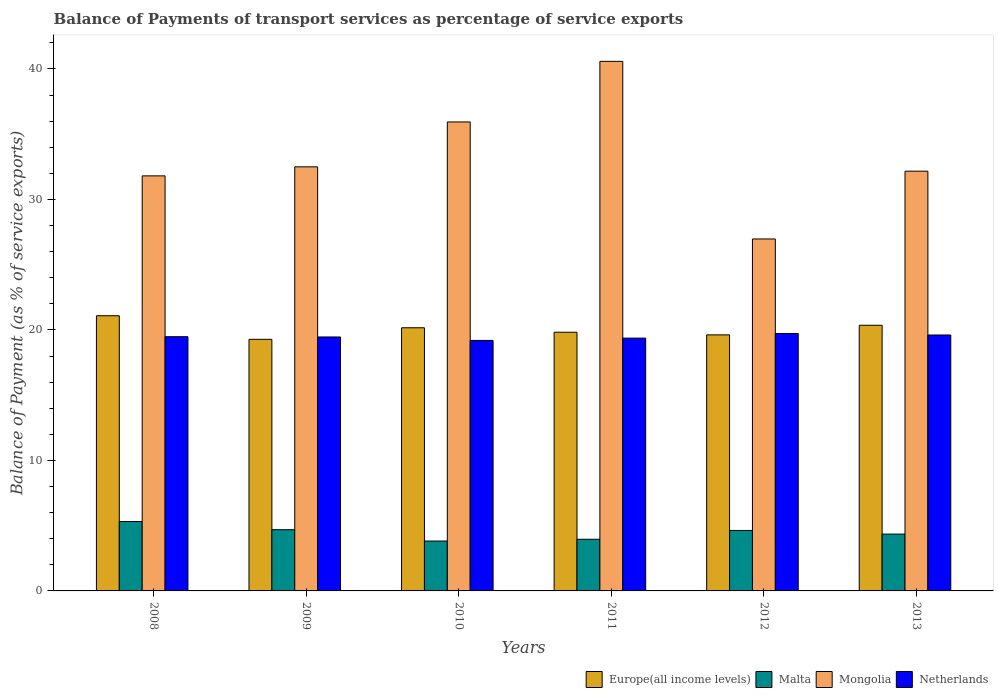Are the number of bars per tick equal to the number of legend labels?
Your response must be concise. Yes. How many bars are there on the 4th tick from the left?
Make the answer very short. 4. In how many cases, is the number of bars for a given year not equal to the number of legend labels?
Make the answer very short. 0. What is the balance of payments of transport services in Malta in 2008?
Keep it short and to the point. 5.32. Across all years, what is the maximum balance of payments of transport services in Europe(all income levels)?
Your answer should be compact. 21.09. Across all years, what is the minimum balance of payments of transport services in Europe(all income levels)?
Make the answer very short. 19.28. What is the total balance of payments of transport services in Malta in the graph?
Offer a terse response. 26.79. What is the difference between the balance of payments of transport services in Netherlands in 2009 and that in 2013?
Offer a terse response. -0.15. What is the difference between the balance of payments of transport services in Malta in 2008 and the balance of payments of transport services in Mongolia in 2009?
Your answer should be very brief. -27.18. What is the average balance of payments of transport services in Mongolia per year?
Your answer should be compact. 33.33. In the year 2013, what is the difference between the balance of payments of transport services in Netherlands and balance of payments of transport services in Malta?
Your answer should be compact. 15.26. In how many years, is the balance of payments of transport services in Netherlands greater than 28 %?
Your response must be concise. 0. What is the ratio of the balance of payments of transport services in Europe(all income levels) in 2009 to that in 2012?
Give a very brief answer. 0.98. Is the difference between the balance of payments of transport services in Netherlands in 2009 and 2010 greater than the difference between the balance of payments of transport services in Malta in 2009 and 2010?
Offer a terse response. No. What is the difference between the highest and the second highest balance of payments of transport services in Netherlands?
Offer a terse response. 0.12. What is the difference between the highest and the lowest balance of payments of transport services in Netherlands?
Make the answer very short. 0.53. Is the sum of the balance of payments of transport services in Europe(all income levels) in 2009 and 2013 greater than the maximum balance of payments of transport services in Malta across all years?
Your answer should be compact. Yes. What does the 3rd bar from the left in 2012 represents?
Give a very brief answer. Mongolia. What does the 1st bar from the right in 2013 represents?
Offer a very short reply. Netherlands. Is it the case that in every year, the sum of the balance of payments of transport services in Europe(all income levels) and balance of payments of transport services in Malta is greater than the balance of payments of transport services in Mongolia?
Your answer should be compact. No. How many years are there in the graph?
Offer a very short reply. 6. What is the difference between two consecutive major ticks on the Y-axis?
Your answer should be very brief. 10. Does the graph contain any zero values?
Keep it short and to the point. No. What is the title of the graph?
Keep it short and to the point. Balance of Payments of transport services as percentage of service exports. What is the label or title of the X-axis?
Your answer should be very brief. Years. What is the label or title of the Y-axis?
Your answer should be compact. Balance of Payment (as % of service exports). What is the Balance of Payment (as % of service exports) in Europe(all income levels) in 2008?
Offer a very short reply. 21.09. What is the Balance of Payment (as % of service exports) of Malta in 2008?
Your answer should be compact. 5.32. What is the Balance of Payment (as % of service exports) in Mongolia in 2008?
Keep it short and to the point. 31.81. What is the Balance of Payment (as % of service exports) in Netherlands in 2008?
Your answer should be very brief. 19.48. What is the Balance of Payment (as % of service exports) in Europe(all income levels) in 2009?
Keep it short and to the point. 19.28. What is the Balance of Payment (as % of service exports) of Malta in 2009?
Provide a short and direct response. 4.69. What is the Balance of Payment (as % of service exports) in Mongolia in 2009?
Make the answer very short. 32.5. What is the Balance of Payment (as % of service exports) in Netherlands in 2009?
Your response must be concise. 19.46. What is the Balance of Payment (as % of service exports) in Europe(all income levels) in 2010?
Your response must be concise. 20.17. What is the Balance of Payment (as % of service exports) in Malta in 2010?
Offer a very short reply. 3.82. What is the Balance of Payment (as % of service exports) of Mongolia in 2010?
Offer a terse response. 35.94. What is the Balance of Payment (as % of service exports) in Netherlands in 2010?
Your response must be concise. 19.2. What is the Balance of Payment (as % of service exports) in Europe(all income levels) in 2011?
Make the answer very short. 19.83. What is the Balance of Payment (as % of service exports) of Malta in 2011?
Make the answer very short. 3.96. What is the Balance of Payment (as % of service exports) in Mongolia in 2011?
Ensure brevity in your answer.  40.59. What is the Balance of Payment (as % of service exports) in Netherlands in 2011?
Give a very brief answer. 19.37. What is the Balance of Payment (as % of service exports) in Europe(all income levels) in 2012?
Your answer should be compact. 19.62. What is the Balance of Payment (as % of service exports) of Malta in 2012?
Your answer should be compact. 4.64. What is the Balance of Payment (as % of service exports) in Mongolia in 2012?
Give a very brief answer. 26.97. What is the Balance of Payment (as % of service exports) in Netherlands in 2012?
Ensure brevity in your answer.  19.73. What is the Balance of Payment (as % of service exports) of Europe(all income levels) in 2013?
Offer a very short reply. 20.36. What is the Balance of Payment (as % of service exports) in Malta in 2013?
Your answer should be very brief. 4.36. What is the Balance of Payment (as % of service exports) of Mongolia in 2013?
Your answer should be compact. 32.17. What is the Balance of Payment (as % of service exports) of Netherlands in 2013?
Provide a succinct answer. 19.61. Across all years, what is the maximum Balance of Payment (as % of service exports) of Europe(all income levels)?
Your answer should be very brief. 21.09. Across all years, what is the maximum Balance of Payment (as % of service exports) in Malta?
Provide a succinct answer. 5.32. Across all years, what is the maximum Balance of Payment (as % of service exports) in Mongolia?
Offer a terse response. 40.59. Across all years, what is the maximum Balance of Payment (as % of service exports) in Netherlands?
Ensure brevity in your answer.  19.73. Across all years, what is the minimum Balance of Payment (as % of service exports) of Europe(all income levels)?
Offer a terse response. 19.28. Across all years, what is the minimum Balance of Payment (as % of service exports) of Malta?
Your answer should be compact. 3.82. Across all years, what is the minimum Balance of Payment (as % of service exports) in Mongolia?
Your answer should be very brief. 26.97. Across all years, what is the minimum Balance of Payment (as % of service exports) of Netherlands?
Ensure brevity in your answer.  19.2. What is the total Balance of Payment (as % of service exports) in Europe(all income levels) in the graph?
Your answer should be very brief. 120.35. What is the total Balance of Payment (as % of service exports) in Malta in the graph?
Provide a short and direct response. 26.79. What is the total Balance of Payment (as % of service exports) of Mongolia in the graph?
Provide a succinct answer. 199.98. What is the total Balance of Payment (as % of service exports) in Netherlands in the graph?
Your response must be concise. 116.86. What is the difference between the Balance of Payment (as % of service exports) in Europe(all income levels) in 2008 and that in 2009?
Ensure brevity in your answer.  1.81. What is the difference between the Balance of Payment (as % of service exports) of Malta in 2008 and that in 2009?
Your response must be concise. 0.63. What is the difference between the Balance of Payment (as % of service exports) in Mongolia in 2008 and that in 2009?
Keep it short and to the point. -0.69. What is the difference between the Balance of Payment (as % of service exports) in Netherlands in 2008 and that in 2009?
Give a very brief answer. 0.02. What is the difference between the Balance of Payment (as % of service exports) in Malta in 2008 and that in 2010?
Provide a short and direct response. 1.5. What is the difference between the Balance of Payment (as % of service exports) of Mongolia in 2008 and that in 2010?
Provide a short and direct response. -4.13. What is the difference between the Balance of Payment (as % of service exports) in Netherlands in 2008 and that in 2010?
Your answer should be very brief. 0.29. What is the difference between the Balance of Payment (as % of service exports) of Europe(all income levels) in 2008 and that in 2011?
Your answer should be very brief. 1.26. What is the difference between the Balance of Payment (as % of service exports) of Malta in 2008 and that in 2011?
Provide a short and direct response. 1.36. What is the difference between the Balance of Payment (as % of service exports) of Mongolia in 2008 and that in 2011?
Make the answer very short. -8.78. What is the difference between the Balance of Payment (as % of service exports) in Netherlands in 2008 and that in 2011?
Ensure brevity in your answer.  0.11. What is the difference between the Balance of Payment (as % of service exports) in Europe(all income levels) in 2008 and that in 2012?
Your response must be concise. 1.47. What is the difference between the Balance of Payment (as % of service exports) of Malta in 2008 and that in 2012?
Make the answer very short. 0.68. What is the difference between the Balance of Payment (as % of service exports) in Mongolia in 2008 and that in 2012?
Ensure brevity in your answer.  4.84. What is the difference between the Balance of Payment (as % of service exports) of Netherlands in 2008 and that in 2012?
Your response must be concise. -0.25. What is the difference between the Balance of Payment (as % of service exports) in Europe(all income levels) in 2008 and that in 2013?
Ensure brevity in your answer.  0.73. What is the difference between the Balance of Payment (as % of service exports) in Malta in 2008 and that in 2013?
Offer a very short reply. 0.96. What is the difference between the Balance of Payment (as % of service exports) of Mongolia in 2008 and that in 2013?
Keep it short and to the point. -0.36. What is the difference between the Balance of Payment (as % of service exports) in Netherlands in 2008 and that in 2013?
Your response must be concise. -0.13. What is the difference between the Balance of Payment (as % of service exports) in Europe(all income levels) in 2009 and that in 2010?
Your response must be concise. -0.89. What is the difference between the Balance of Payment (as % of service exports) in Malta in 2009 and that in 2010?
Provide a short and direct response. 0.87. What is the difference between the Balance of Payment (as % of service exports) in Mongolia in 2009 and that in 2010?
Provide a succinct answer. -3.44. What is the difference between the Balance of Payment (as % of service exports) of Netherlands in 2009 and that in 2010?
Your answer should be compact. 0.27. What is the difference between the Balance of Payment (as % of service exports) in Europe(all income levels) in 2009 and that in 2011?
Provide a succinct answer. -0.55. What is the difference between the Balance of Payment (as % of service exports) of Malta in 2009 and that in 2011?
Offer a very short reply. 0.73. What is the difference between the Balance of Payment (as % of service exports) in Mongolia in 2009 and that in 2011?
Offer a terse response. -8.08. What is the difference between the Balance of Payment (as % of service exports) of Netherlands in 2009 and that in 2011?
Give a very brief answer. 0.09. What is the difference between the Balance of Payment (as % of service exports) of Europe(all income levels) in 2009 and that in 2012?
Offer a terse response. -0.34. What is the difference between the Balance of Payment (as % of service exports) of Malta in 2009 and that in 2012?
Make the answer very short. 0.06. What is the difference between the Balance of Payment (as % of service exports) of Mongolia in 2009 and that in 2012?
Offer a terse response. 5.53. What is the difference between the Balance of Payment (as % of service exports) in Netherlands in 2009 and that in 2012?
Your answer should be very brief. -0.27. What is the difference between the Balance of Payment (as % of service exports) of Europe(all income levels) in 2009 and that in 2013?
Ensure brevity in your answer.  -1.08. What is the difference between the Balance of Payment (as % of service exports) in Malta in 2009 and that in 2013?
Give a very brief answer. 0.34. What is the difference between the Balance of Payment (as % of service exports) of Mongolia in 2009 and that in 2013?
Offer a terse response. 0.33. What is the difference between the Balance of Payment (as % of service exports) of Netherlands in 2009 and that in 2013?
Your answer should be very brief. -0.15. What is the difference between the Balance of Payment (as % of service exports) in Europe(all income levels) in 2010 and that in 2011?
Your response must be concise. 0.34. What is the difference between the Balance of Payment (as % of service exports) of Malta in 2010 and that in 2011?
Offer a terse response. -0.14. What is the difference between the Balance of Payment (as % of service exports) in Mongolia in 2010 and that in 2011?
Provide a succinct answer. -4.64. What is the difference between the Balance of Payment (as % of service exports) of Netherlands in 2010 and that in 2011?
Provide a short and direct response. -0.18. What is the difference between the Balance of Payment (as % of service exports) of Europe(all income levels) in 2010 and that in 2012?
Provide a succinct answer. 0.54. What is the difference between the Balance of Payment (as % of service exports) of Malta in 2010 and that in 2012?
Provide a short and direct response. -0.81. What is the difference between the Balance of Payment (as % of service exports) of Mongolia in 2010 and that in 2012?
Keep it short and to the point. 8.97. What is the difference between the Balance of Payment (as % of service exports) of Netherlands in 2010 and that in 2012?
Provide a short and direct response. -0.53. What is the difference between the Balance of Payment (as % of service exports) of Europe(all income levels) in 2010 and that in 2013?
Keep it short and to the point. -0.19. What is the difference between the Balance of Payment (as % of service exports) of Malta in 2010 and that in 2013?
Make the answer very short. -0.53. What is the difference between the Balance of Payment (as % of service exports) in Mongolia in 2010 and that in 2013?
Your response must be concise. 3.77. What is the difference between the Balance of Payment (as % of service exports) in Netherlands in 2010 and that in 2013?
Provide a succinct answer. -0.42. What is the difference between the Balance of Payment (as % of service exports) of Europe(all income levels) in 2011 and that in 2012?
Give a very brief answer. 0.2. What is the difference between the Balance of Payment (as % of service exports) of Malta in 2011 and that in 2012?
Provide a short and direct response. -0.68. What is the difference between the Balance of Payment (as % of service exports) of Mongolia in 2011 and that in 2012?
Offer a terse response. 13.61. What is the difference between the Balance of Payment (as % of service exports) in Netherlands in 2011 and that in 2012?
Your response must be concise. -0.36. What is the difference between the Balance of Payment (as % of service exports) of Europe(all income levels) in 2011 and that in 2013?
Give a very brief answer. -0.53. What is the difference between the Balance of Payment (as % of service exports) of Malta in 2011 and that in 2013?
Make the answer very short. -0.4. What is the difference between the Balance of Payment (as % of service exports) in Mongolia in 2011 and that in 2013?
Keep it short and to the point. 8.42. What is the difference between the Balance of Payment (as % of service exports) of Netherlands in 2011 and that in 2013?
Your answer should be very brief. -0.24. What is the difference between the Balance of Payment (as % of service exports) in Europe(all income levels) in 2012 and that in 2013?
Provide a short and direct response. -0.73. What is the difference between the Balance of Payment (as % of service exports) in Malta in 2012 and that in 2013?
Ensure brevity in your answer.  0.28. What is the difference between the Balance of Payment (as % of service exports) of Mongolia in 2012 and that in 2013?
Keep it short and to the point. -5.19. What is the difference between the Balance of Payment (as % of service exports) of Netherlands in 2012 and that in 2013?
Your answer should be compact. 0.12. What is the difference between the Balance of Payment (as % of service exports) in Europe(all income levels) in 2008 and the Balance of Payment (as % of service exports) in Malta in 2009?
Provide a succinct answer. 16.4. What is the difference between the Balance of Payment (as % of service exports) in Europe(all income levels) in 2008 and the Balance of Payment (as % of service exports) in Mongolia in 2009?
Provide a succinct answer. -11.41. What is the difference between the Balance of Payment (as % of service exports) in Europe(all income levels) in 2008 and the Balance of Payment (as % of service exports) in Netherlands in 2009?
Ensure brevity in your answer.  1.63. What is the difference between the Balance of Payment (as % of service exports) in Malta in 2008 and the Balance of Payment (as % of service exports) in Mongolia in 2009?
Provide a short and direct response. -27.18. What is the difference between the Balance of Payment (as % of service exports) of Malta in 2008 and the Balance of Payment (as % of service exports) of Netherlands in 2009?
Give a very brief answer. -14.14. What is the difference between the Balance of Payment (as % of service exports) in Mongolia in 2008 and the Balance of Payment (as % of service exports) in Netherlands in 2009?
Make the answer very short. 12.35. What is the difference between the Balance of Payment (as % of service exports) of Europe(all income levels) in 2008 and the Balance of Payment (as % of service exports) of Malta in 2010?
Your answer should be very brief. 17.27. What is the difference between the Balance of Payment (as % of service exports) in Europe(all income levels) in 2008 and the Balance of Payment (as % of service exports) in Mongolia in 2010?
Your response must be concise. -14.85. What is the difference between the Balance of Payment (as % of service exports) in Europe(all income levels) in 2008 and the Balance of Payment (as % of service exports) in Netherlands in 2010?
Offer a very short reply. 1.89. What is the difference between the Balance of Payment (as % of service exports) of Malta in 2008 and the Balance of Payment (as % of service exports) of Mongolia in 2010?
Give a very brief answer. -30.62. What is the difference between the Balance of Payment (as % of service exports) in Malta in 2008 and the Balance of Payment (as % of service exports) in Netherlands in 2010?
Ensure brevity in your answer.  -13.88. What is the difference between the Balance of Payment (as % of service exports) of Mongolia in 2008 and the Balance of Payment (as % of service exports) of Netherlands in 2010?
Offer a very short reply. 12.61. What is the difference between the Balance of Payment (as % of service exports) of Europe(all income levels) in 2008 and the Balance of Payment (as % of service exports) of Malta in 2011?
Keep it short and to the point. 17.13. What is the difference between the Balance of Payment (as % of service exports) of Europe(all income levels) in 2008 and the Balance of Payment (as % of service exports) of Mongolia in 2011?
Keep it short and to the point. -19.49. What is the difference between the Balance of Payment (as % of service exports) of Europe(all income levels) in 2008 and the Balance of Payment (as % of service exports) of Netherlands in 2011?
Provide a short and direct response. 1.72. What is the difference between the Balance of Payment (as % of service exports) in Malta in 2008 and the Balance of Payment (as % of service exports) in Mongolia in 2011?
Your response must be concise. -35.27. What is the difference between the Balance of Payment (as % of service exports) of Malta in 2008 and the Balance of Payment (as % of service exports) of Netherlands in 2011?
Offer a terse response. -14.05. What is the difference between the Balance of Payment (as % of service exports) in Mongolia in 2008 and the Balance of Payment (as % of service exports) in Netherlands in 2011?
Make the answer very short. 12.43. What is the difference between the Balance of Payment (as % of service exports) in Europe(all income levels) in 2008 and the Balance of Payment (as % of service exports) in Malta in 2012?
Your answer should be compact. 16.46. What is the difference between the Balance of Payment (as % of service exports) in Europe(all income levels) in 2008 and the Balance of Payment (as % of service exports) in Mongolia in 2012?
Your response must be concise. -5.88. What is the difference between the Balance of Payment (as % of service exports) in Europe(all income levels) in 2008 and the Balance of Payment (as % of service exports) in Netherlands in 2012?
Your answer should be very brief. 1.36. What is the difference between the Balance of Payment (as % of service exports) of Malta in 2008 and the Balance of Payment (as % of service exports) of Mongolia in 2012?
Your answer should be compact. -21.65. What is the difference between the Balance of Payment (as % of service exports) of Malta in 2008 and the Balance of Payment (as % of service exports) of Netherlands in 2012?
Ensure brevity in your answer.  -14.41. What is the difference between the Balance of Payment (as % of service exports) of Mongolia in 2008 and the Balance of Payment (as % of service exports) of Netherlands in 2012?
Offer a very short reply. 12.08. What is the difference between the Balance of Payment (as % of service exports) of Europe(all income levels) in 2008 and the Balance of Payment (as % of service exports) of Malta in 2013?
Make the answer very short. 16.73. What is the difference between the Balance of Payment (as % of service exports) of Europe(all income levels) in 2008 and the Balance of Payment (as % of service exports) of Mongolia in 2013?
Keep it short and to the point. -11.08. What is the difference between the Balance of Payment (as % of service exports) of Europe(all income levels) in 2008 and the Balance of Payment (as % of service exports) of Netherlands in 2013?
Offer a very short reply. 1.48. What is the difference between the Balance of Payment (as % of service exports) of Malta in 2008 and the Balance of Payment (as % of service exports) of Mongolia in 2013?
Ensure brevity in your answer.  -26.85. What is the difference between the Balance of Payment (as % of service exports) of Malta in 2008 and the Balance of Payment (as % of service exports) of Netherlands in 2013?
Your answer should be compact. -14.29. What is the difference between the Balance of Payment (as % of service exports) in Mongolia in 2008 and the Balance of Payment (as % of service exports) in Netherlands in 2013?
Offer a terse response. 12.19. What is the difference between the Balance of Payment (as % of service exports) of Europe(all income levels) in 2009 and the Balance of Payment (as % of service exports) of Malta in 2010?
Keep it short and to the point. 15.46. What is the difference between the Balance of Payment (as % of service exports) in Europe(all income levels) in 2009 and the Balance of Payment (as % of service exports) in Mongolia in 2010?
Ensure brevity in your answer.  -16.66. What is the difference between the Balance of Payment (as % of service exports) of Europe(all income levels) in 2009 and the Balance of Payment (as % of service exports) of Netherlands in 2010?
Keep it short and to the point. 0.08. What is the difference between the Balance of Payment (as % of service exports) in Malta in 2009 and the Balance of Payment (as % of service exports) in Mongolia in 2010?
Ensure brevity in your answer.  -31.25. What is the difference between the Balance of Payment (as % of service exports) in Malta in 2009 and the Balance of Payment (as % of service exports) in Netherlands in 2010?
Your answer should be compact. -14.51. What is the difference between the Balance of Payment (as % of service exports) of Mongolia in 2009 and the Balance of Payment (as % of service exports) of Netherlands in 2010?
Your answer should be compact. 13.3. What is the difference between the Balance of Payment (as % of service exports) of Europe(all income levels) in 2009 and the Balance of Payment (as % of service exports) of Malta in 2011?
Your answer should be very brief. 15.32. What is the difference between the Balance of Payment (as % of service exports) in Europe(all income levels) in 2009 and the Balance of Payment (as % of service exports) in Mongolia in 2011?
Your response must be concise. -21.3. What is the difference between the Balance of Payment (as % of service exports) in Europe(all income levels) in 2009 and the Balance of Payment (as % of service exports) in Netherlands in 2011?
Ensure brevity in your answer.  -0.09. What is the difference between the Balance of Payment (as % of service exports) in Malta in 2009 and the Balance of Payment (as % of service exports) in Mongolia in 2011?
Your response must be concise. -35.89. What is the difference between the Balance of Payment (as % of service exports) of Malta in 2009 and the Balance of Payment (as % of service exports) of Netherlands in 2011?
Offer a terse response. -14.68. What is the difference between the Balance of Payment (as % of service exports) of Mongolia in 2009 and the Balance of Payment (as % of service exports) of Netherlands in 2011?
Keep it short and to the point. 13.13. What is the difference between the Balance of Payment (as % of service exports) in Europe(all income levels) in 2009 and the Balance of Payment (as % of service exports) in Malta in 2012?
Provide a succinct answer. 14.65. What is the difference between the Balance of Payment (as % of service exports) in Europe(all income levels) in 2009 and the Balance of Payment (as % of service exports) in Mongolia in 2012?
Offer a terse response. -7.69. What is the difference between the Balance of Payment (as % of service exports) in Europe(all income levels) in 2009 and the Balance of Payment (as % of service exports) in Netherlands in 2012?
Provide a short and direct response. -0.45. What is the difference between the Balance of Payment (as % of service exports) of Malta in 2009 and the Balance of Payment (as % of service exports) of Mongolia in 2012?
Keep it short and to the point. -22.28. What is the difference between the Balance of Payment (as % of service exports) of Malta in 2009 and the Balance of Payment (as % of service exports) of Netherlands in 2012?
Your response must be concise. -15.04. What is the difference between the Balance of Payment (as % of service exports) of Mongolia in 2009 and the Balance of Payment (as % of service exports) of Netherlands in 2012?
Make the answer very short. 12.77. What is the difference between the Balance of Payment (as % of service exports) of Europe(all income levels) in 2009 and the Balance of Payment (as % of service exports) of Malta in 2013?
Offer a very short reply. 14.92. What is the difference between the Balance of Payment (as % of service exports) in Europe(all income levels) in 2009 and the Balance of Payment (as % of service exports) in Mongolia in 2013?
Give a very brief answer. -12.89. What is the difference between the Balance of Payment (as % of service exports) in Europe(all income levels) in 2009 and the Balance of Payment (as % of service exports) in Netherlands in 2013?
Ensure brevity in your answer.  -0.33. What is the difference between the Balance of Payment (as % of service exports) in Malta in 2009 and the Balance of Payment (as % of service exports) in Mongolia in 2013?
Your answer should be compact. -27.48. What is the difference between the Balance of Payment (as % of service exports) in Malta in 2009 and the Balance of Payment (as % of service exports) in Netherlands in 2013?
Your response must be concise. -14.92. What is the difference between the Balance of Payment (as % of service exports) in Mongolia in 2009 and the Balance of Payment (as % of service exports) in Netherlands in 2013?
Offer a very short reply. 12.89. What is the difference between the Balance of Payment (as % of service exports) in Europe(all income levels) in 2010 and the Balance of Payment (as % of service exports) in Malta in 2011?
Provide a succinct answer. 16.21. What is the difference between the Balance of Payment (as % of service exports) in Europe(all income levels) in 2010 and the Balance of Payment (as % of service exports) in Mongolia in 2011?
Give a very brief answer. -20.42. What is the difference between the Balance of Payment (as % of service exports) in Europe(all income levels) in 2010 and the Balance of Payment (as % of service exports) in Netherlands in 2011?
Ensure brevity in your answer.  0.79. What is the difference between the Balance of Payment (as % of service exports) in Malta in 2010 and the Balance of Payment (as % of service exports) in Mongolia in 2011?
Your answer should be compact. -36.76. What is the difference between the Balance of Payment (as % of service exports) of Malta in 2010 and the Balance of Payment (as % of service exports) of Netherlands in 2011?
Your answer should be very brief. -15.55. What is the difference between the Balance of Payment (as % of service exports) in Mongolia in 2010 and the Balance of Payment (as % of service exports) in Netherlands in 2011?
Your answer should be very brief. 16.57. What is the difference between the Balance of Payment (as % of service exports) in Europe(all income levels) in 2010 and the Balance of Payment (as % of service exports) in Malta in 2012?
Your response must be concise. 15.53. What is the difference between the Balance of Payment (as % of service exports) of Europe(all income levels) in 2010 and the Balance of Payment (as % of service exports) of Mongolia in 2012?
Your response must be concise. -6.81. What is the difference between the Balance of Payment (as % of service exports) of Europe(all income levels) in 2010 and the Balance of Payment (as % of service exports) of Netherlands in 2012?
Your response must be concise. 0.44. What is the difference between the Balance of Payment (as % of service exports) in Malta in 2010 and the Balance of Payment (as % of service exports) in Mongolia in 2012?
Provide a succinct answer. -23.15. What is the difference between the Balance of Payment (as % of service exports) of Malta in 2010 and the Balance of Payment (as % of service exports) of Netherlands in 2012?
Provide a short and direct response. -15.91. What is the difference between the Balance of Payment (as % of service exports) of Mongolia in 2010 and the Balance of Payment (as % of service exports) of Netherlands in 2012?
Ensure brevity in your answer.  16.21. What is the difference between the Balance of Payment (as % of service exports) of Europe(all income levels) in 2010 and the Balance of Payment (as % of service exports) of Malta in 2013?
Keep it short and to the point. 15.81. What is the difference between the Balance of Payment (as % of service exports) of Europe(all income levels) in 2010 and the Balance of Payment (as % of service exports) of Mongolia in 2013?
Your response must be concise. -12. What is the difference between the Balance of Payment (as % of service exports) of Europe(all income levels) in 2010 and the Balance of Payment (as % of service exports) of Netherlands in 2013?
Offer a very short reply. 0.55. What is the difference between the Balance of Payment (as % of service exports) in Malta in 2010 and the Balance of Payment (as % of service exports) in Mongolia in 2013?
Provide a succinct answer. -28.35. What is the difference between the Balance of Payment (as % of service exports) in Malta in 2010 and the Balance of Payment (as % of service exports) in Netherlands in 2013?
Make the answer very short. -15.79. What is the difference between the Balance of Payment (as % of service exports) in Mongolia in 2010 and the Balance of Payment (as % of service exports) in Netherlands in 2013?
Provide a succinct answer. 16.33. What is the difference between the Balance of Payment (as % of service exports) in Europe(all income levels) in 2011 and the Balance of Payment (as % of service exports) in Malta in 2012?
Keep it short and to the point. 15.19. What is the difference between the Balance of Payment (as % of service exports) of Europe(all income levels) in 2011 and the Balance of Payment (as % of service exports) of Mongolia in 2012?
Ensure brevity in your answer.  -7.15. What is the difference between the Balance of Payment (as % of service exports) of Europe(all income levels) in 2011 and the Balance of Payment (as % of service exports) of Netherlands in 2012?
Ensure brevity in your answer.  0.1. What is the difference between the Balance of Payment (as % of service exports) in Malta in 2011 and the Balance of Payment (as % of service exports) in Mongolia in 2012?
Offer a terse response. -23.01. What is the difference between the Balance of Payment (as % of service exports) in Malta in 2011 and the Balance of Payment (as % of service exports) in Netherlands in 2012?
Ensure brevity in your answer.  -15.77. What is the difference between the Balance of Payment (as % of service exports) in Mongolia in 2011 and the Balance of Payment (as % of service exports) in Netherlands in 2012?
Keep it short and to the point. 20.86. What is the difference between the Balance of Payment (as % of service exports) in Europe(all income levels) in 2011 and the Balance of Payment (as % of service exports) in Malta in 2013?
Your answer should be compact. 15.47. What is the difference between the Balance of Payment (as % of service exports) of Europe(all income levels) in 2011 and the Balance of Payment (as % of service exports) of Mongolia in 2013?
Keep it short and to the point. -12.34. What is the difference between the Balance of Payment (as % of service exports) in Europe(all income levels) in 2011 and the Balance of Payment (as % of service exports) in Netherlands in 2013?
Offer a very short reply. 0.21. What is the difference between the Balance of Payment (as % of service exports) in Malta in 2011 and the Balance of Payment (as % of service exports) in Mongolia in 2013?
Your response must be concise. -28.21. What is the difference between the Balance of Payment (as % of service exports) in Malta in 2011 and the Balance of Payment (as % of service exports) in Netherlands in 2013?
Offer a terse response. -15.65. What is the difference between the Balance of Payment (as % of service exports) in Mongolia in 2011 and the Balance of Payment (as % of service exports) in Netherlands in 2013?
Your answer should be compact. 20.97. What is the difference between the Balance of Payment (as % of service exports) in Europe(all income levels) in 2012 and the Balance of Payment (as % of service exports) in Malta in 2013?
Your response must be concise. 15.27. What is the difference between the Balance of Payment (as % of service exports) in Europe(all income levels) in 2012 and the Balance of Payment (as % of service exports) in Mongolia in 2013?
Provide a short and direct response. -12.54. What is the difference between the Balance of Payment (as % of service exports) of Europe(all income levels) in 2012 and the Balance of Payment (as % of service exports) of Netherlands in 2013?
Give a very brief answer. 0.01. What is the difference between the Balance of Payment (as % of service exports) of Malta in 2012 and the Balance of Payment (as % of service exports) of Mongolia in 2013?
Give a very brief answer. -27.53. What is the difference between the Balance of Payment (as % of service exports) in Malta in 2012 and the Balance of Payment (as % of service exports) in Netherlands in 2013?
Your response must be concise. -14.98. What is the difference between the Balance of Payment (as % of service exports) in Mongolia in 2012 and the Balance of Payment (as % of service exports) in Netherlands in 2013?
Make the answer very short. 7.36. What is the average Balance of Payment (as % of service exports) of Europe(all income levels) per year?
Your response must be concise. 20.06. What is the average Balance of Payment (as % of service exports) in Malta per year?
Ensure brevity in your answer.  4.46. What is the average Balance of Payment (as % of service exports) of Mongolia per year?
Make the answer very short. 33.33. What is the average Balance of Payment (as % of service exports) of Netherlands per year?
Your answer should be compact. 19.48. In the year 2008, what is the difference between the Balance of Payment (as % of service exports) in Europe(all income levels) and Balance of Payment (as % of service exports) in Malta?
Offer a very short reply. 15.77. In the year 2008, what is the difference between the Balance of Payment (as % of service exports) in Europe(all income levels) and Balance of Payment (as % of service exports) in Mongolia?
Ensure brevity in your answer.  -10.72. In the year 2008, what is the difference between the Balance of Payment (as % of service exports) in Europe(all income levels) and Balance of Payment (as % of service exports) in Netherlands?
Give a very brief answer. 1.61. In the year 2008, what is the difference between the Balance of Payment (as % of service exports) of Malta and Balance of Payment (as % of service exports) of Mongolia?
Your answer should be compact. -26.49. In the year 2008, what is the difference between the Balance of Payment (as % of service exports) of Malta and Balance of Payment (as % of service exports) of Netherlands?
Ensure brevity in your answer.  -14.16. In the year 2008, what is the difference between the Balance of Payment (as % of service exports) of Mongolia and Balance of Payment (as % of service exports) of Netherlands?
Your answer should be very brief. 12.33. In the year 2009, what is the difference between the Balance of Payment (as % of service exports) of Europe(all income levels) and Balance of Payment (as % of service exports) of Malta?
Make the answer very short. 14.59. In the year 2009, what is the difference between the Balance of Payment (as % of service exports) of Europe(all income levels) and Balance of Payment (as % of service exports) of Mongolia?
Keep it short and to the point. -13.22. In the year 2009, what is the difference between the Balance of Payment (as % of service exports) in Europe(all income levels) and Balance of Payment (as % of service exports) in Netherlands?
Your response must be concise. -0.18. In the year 2009, what is the difference between the Balance of Payment (as % of service exports) of Malta and Balance of Payment (as % of service exports) of Mongolia?
Make the answer very short. -27.81. In the year 2009, what is the difference between the Balance of Payment (as % of service exports) in Malta and Balance of Payment (as % of service exports) in Netherlands?
Keep it short and to the point. -14.77. In the year 2009, what is the difference between the Balance of Payment (as % of service exports) in Mongolia and Balance of Payment (as % of service exports) in Netherlands?
Give a very brief answer. 13.04. In the year 2010, what is the difference between the Balance of Payment (as % of service exports) of Europe(all income levels) and Balance of Payment (as % of service exports) of Malta?
Give a very brief answer. 16.34. In the year 2010, what is the difference between the Balance of Payment (as % of service exports) of Europe(all income levels) and Balance of Payment (as % of service exports) of Mongolia?
Keep it short and to the point. -15.77. In the year 2010, what is the difference between the Balance of Payment (as % of service exports) of Europe(all income levels) and Balance of Payment (as % of service exports) of Netherlands?
Your response must be concise. 0.97. In the year 2010, what is the difference between the Balance of Payment (as % of service exports) in Malta and Balance of Payment (as % of service exports) in Mongolia?
Ensure brevity in your answer.  -32.12. In the year 2010, what is the difference between the Balance of Payment (as % of service exports) in Malta and Balance of Payment (as % of service exports) in Netherlands?
Make the answer very short. -15.37. In the year 2010, what is the difference between the Balance of Payment (as % of service exports) in Mongolia and Balance of Payment (as % of service exports) in Netherlands?
Give a very brief answer. 16.74. In the year 2011, what is the difference between the Balance of Payment (as % of service exports) in Europe(all income levels) and Balance of Payment (as % of service exports) in Malta?
Your response must be concise. 15.87. In the year 2011, what is the difference between the Balance of Payment (as % of service exports) in Europe(all income levels) and Balance of Payment (as % of service exports) in Mongolia?
Give a very brief answer. -20.76. In the year 2011, what is the difference between the Balance of Payment (as % of service exports) of Europe(all income levels) and Balance of Payment (as % of service exports) of Netherlands?
Offer a very short reply. 0.45. In the year 2011, what is the difference between the Balance of Payment (as % of service exports) of Malta and Balance of Payment (as % of service exports) of Mongolia?
Make the answer very short. -36.63. In the year 2011, what is the difference between the Balance of Payment (as % of service exports) of Malta and Balance of Payment (as % of service exports) of Netherlands?
Make the answer very short. -15.41. In the year 2011, what is the difference between the Balance of Payment (as % of service exports) of Mongolia and Balance of Payment (as % of service exports) of Netherlands?
Your response must be concise. 21.21. In the year 2012, what is the difference between the Balance of Payment (as % of service exports) in Europe(all income levels) and Balance of Payment (as % of service exports) in Malta?
Your answer should be very brief. 14.99. In the year 2012, what is the difference between the Balance of Payment (as % of service exports) of Europe(all income levels) and Balance of Payment (as % of service exports) of Mongolia?
Provide a short and direct response. -7.35. In the year 2012, what is the difference between the Balance of Payment (as % of service exports) in Europe(all income levels) and Balance of Payment (as % of service exports) in Netherlands?
Keep it short and to the point. -0.11. In the year 2012, what is the difference between the Balance of Payment (as % of service exports) of Malta and Balance of Payment (as % of service exports) of Mongolia?
Offer a terse response. -22.34. In the year 2012, what is the difference between the Balance of Payment (as % of service exports) of Malta and Balance of Payment (as % of service exports) of Netherlands?
Your answer should be very brief. -15.09. In the year 2012, what is the difference between the Balance of Payment (as % of service exports) in Mongolia and Balance of Payment (as % of service exports) in Netherlands?
Offer a terse response. 7.24. In the year 2013, what is the difference between the Balance of Payment (as % of service exports) in Europe(all income levels) and Balance of Payment (as % of service exports) in Malta?
Provide a succinct answer. 16. In the year 2013, what is the difference between the Balance of Payment (as % of service exports) in Europe(all income levels) and Balance of Payment (as % of service exports) in Mongolia?
Make the answer very short. -11.81. In the year 2013, what is the difference between the Balance of Payment (as % of service exports) in Europe(all income levels) and Balance of Payment (as % of service exports) in Netherlands?
Your answer should be very brief. 0.74. In the year 2013, what is the difference between the Balance of Payment (as % of service exports) of Malta and Balance of Payment (as % of service exports) of Mongolia?
Keep it short and to the point. -27.81. In the year 2013, what is the difference between the Balance of Payment (as % of service exports) of Malta and Balance of Payment (as % of service exports) of Netherlands?
Ensure brevity in your answer.  -15.26. In the year 2013, what is the difference between the Balance of Payment (as % of service exports) in Mongolia and Balance of Payment (as % of service exports) in Netherlands?
Offer a terse response. 12.55. What is the ratio of the Balance of Payment (as % of service exports) in Europe(all income levels) in 2008 to that in 2009?
Offer a terse response. 1.09. What is the ratio of the Balance of Payment (as % of service exports) of Malta in 2008 to that in 2009?
Provide a short and direct response. 1.13. What is the ratio of the Balance of Payment (as % of service exports) in Mongolia in 2008 to that in 2009?
Ensure brevity in your answer.  0.98. What is the ratio of the Balance of Payment (as % of service exports) of Europe(all income levels) in 2008 to that in 2010?
Give a very brief answer. 1.05. What is the ratio of the Balance of Payment (as % of service exports) of Malta in 2008 to that in 2010?
Offer a very short reply. 1.39. What is the ratio of the Balance of Payment (as % of service exports) in Mongolia in 2008 to that in 2010?
Offer a terse response. 0.89. What is the ratio of the Balance of Payment (as % of service exports) of Netherlands in 2008 to that in 2010?
Make the answer very short. 1.01. What is the ratio of the Balance of Payment (as % of service exports) in Europe(all income levels) in 2008 to that in 2011?
Offer a terse response. 1.06. What is the ratio of the Balance of Payment (as % of service exports) of Malta in 2008 to that in 2011?
Offer a terse response. 1.34. What is the ratio of the Balance of Payment (as % of service exports) of Mongolia in 2008 to that in 2011?
Ensure brevity in your answer.  0.78. What is the ratio of the Balance of Payment (as % of service exports) of Netherlands in 2008 to that in 2011?
Make the answer very short. 1.01. What is the ratio of the Balance of Payment (as % of service exports) in Europe(all income levels) in 2008 to that in 2012?
Your answer should be compact. 1.07. What is the ratio of the Balance of Payment (as % of service exports) in Malta in 2008 to that in 2012?
Your answer should be very brief. 1.15. What is the ratio of the Balance of Payment (as % of service exports) in Mongolia in 2008 to that in 2012?
Provide a succinct answer. 1.18. What is the ratio of the Balance of Payment (as % of service exports) of Netherlands in 2008 to that in 2012?
Provide a short and direct response. 0.99. What is the ratio of the Balance of Payment (as % of service exports) in Europe(all income levels) in 2008 to that in 2013?
Provide a succinct answer. 1.04. What is the ratio of the Balance of Payment (as % of service exports) in Malta in 2008 to that in 2013?
Your answer should be very brief. 1.22. What is the ratio of the Balance of Payment (as % of service exports) of Mongolia in 2008 to that in 2013?
Ensure brevity in your answer.  0.99. What is the ratio of the Balance of Payment (as % of service exports) in Europe(all income levels) in 2009 to that in 2010?
Ensure brevity in your answer.  0.96. What is the ratio of the Balance of Payment (as % of service exports) of Malta in 2009 to that in 2010?
Keep it short and to the point. 1.23. What is the ratio of the Balance of Payment (as % of service exports) in Mongolia in 2009 to that in 2010?
Your answer should be compact. 0.9. What is the ratio of the Balance of Payment (as % of service exports) in Netherlands in 2009 to that in 2010?
Your answer should be very brief. 1.01. What is the ratio of the Balance of Payment (as % of service exports) of Europe(all income levels) in 2009 to that in 2011?
Make the answer very short. 0.97. What is the ratio of the Balance of Payment (as % of service exports) in Malta in 2009 to that in 2011?
Keep it short and to the point. 1.18. What is the ratio of the Balance of Payment (as % of service exports) in Mongolia in 2009 to that in 2011?
Your answer should be very brief. 0.8. What is the ratio of the Balance of Payment (as % of service exports) in Europe(all income levels) in 2009 to that in 2012?
Your answer should be compact. 0.98. What is the ratio of the Balance of Payment (as % of service exports) of Malta in 2009 to that in 2012?
Give a very brief answer. 1.01. What is the ratio of the Balance of Payment (as % of service exports) in Mongolia in 2009 to that in 2012?
Ensure brevity in your answer.  1.2. What is the ratio of the Balance of Payment (as % of service exports) of Netherlands in 2009 to that in 2012?
Provide a short and direct response. 0.99. What is the ratio of the Balance of Payment (as % of service exports) in Europe(all income levels) in 2009 to that in 2013?
Your answer should be compact. 0.95. What is the ratio of the Balance of Payment (as % of service exports) of Malta in 2009 to that in 2013?
Offer a terse response. 1.08. What is the ratio of the Balance of Payment (as % of service exports) in Mongolia in 2009 to that in 2013?
Make the answer very short. 1.01. What is the ratio of the Balance of Payment (as % of service exports) of Netherlands in 2009 to that in 2013?
Your answer should be compact. 0.99. What is the ratio of the Balance of Payment (as % of service exports) of Europe(all income levels) in 2010 to that in 2011?
Keep it short and to the point. 1.02. What is the ratio of the Balance of Payment (as % of service exports) of Malta in 2010 to that in 2011?
Offer a very short reply. 0.97. What is the ratio of the Balance of Payment (as % of service exports) in Mongolia in 2010 to that in 2011?
Make the answer very short. 0.89. What is the ratio of the Balance of Payment (as % of service exports) of Netherlands in 2010 to that in 2011?
Your response must be concise. 0.99. What is the ratio of the Balance of Payment (as % of service exports) of Europe(all income levels) in 2010 to that in 2012?
Give a very brief answer. 1.03. What is the ratio of the Balance of Payment (as % of service exports) in Malta in 2010 to that in 2012?
Your response must be concise. 0.82. What is the ratio of the Balance of Payment (as % of service exports) in Mongolia in 2010 to that in 2012?
Give a very brief answer. 1.33. What is the ratio of the Balance of Payment (as % of service exports) of Netherlands in 2010 to that in 2012?
Your response must be concise. 0.97. What is the ratio of the Balance of Payment (as % of service exports) in Europe(all income levels) in 2010 to that in 2013?
Keep it short and to the point. 0.99. What is the ratio of the Balance of Payment (as % of service exports) of Malta in 2010 to that in 2013?
Your answer should be compact. 0.88. What is the ratio of the Balance of Payment (as % of service exports) of Mongolia in 2010 to that in 2013?
Provide a succinct answer. 1.12. What is the ratio of the Balance of Payment (as % of service exports) in Netherlands in 2010 to that in 2013?
Make the answer very short. 0.98. What is the ratio of the Balance of Payment (as % of service exports) of Europe(all income levels) in 2011 to that in 2012?
Your response must be concise. 1.01. What is the ratio of the Balance of Payment (as % of service exports) of Malta in 2011 to that in 2012?
Your response must be concise. 0.85. What is the ratio of the Balance of Payment (as % of service exports) in Mongolia in 2011 to that in 2012?
Make the answer very short. 1.5. What is the ratio of the Balance of Payment (as % of service exports) in Europe(all income levels) in 2011 to that in 2013?
Provide a short and direct response. 0.97. What is the ratio of the Balance of Payment (as % of service exports) of Malta in 2011 to that in 2013?
Keep it short and to the point. 0.91. What is the ratio of the Balance of Payment (as % of service exports) in Mongolia in 2011 to that in 2013?
Offer a very short reply. 1.26. What is the ratio of the Balance of Payment (as % of service exports) of Netherlands in 2011 to that in 2013?
Give a very brief answer. 0.99. What is the ratio of the Balance of Payment (as % of service exports) in Europe(all income levels) in 2012 to that in 2013?
Provide a short and direct response. 0.96. What is the ratio of the Balance of Payment (as % of service exports) of Malta in 2012 to that in 2013?
Make the answer very short. 1.06. What is the ratio of the Balance of Payment (as % of service exports) in Mongolia in 2012 to that in 2013?
Keep it short and to the point. 0.84. What is the ratio of the Balance of Payment (as % of service exports) of Netherlands in 2012 to that in 2013?
Offer a very short reply. 1.01. What is the difference between the highest and the second highest Balance of Payment (as % of service exports) of Europe(all income levels)?
Your answer should be compact. 0.73. What is the difference between the highest and the second highest Balance of Payment (as % of service exports) of Malta?
Keep it short and to the point. 0.63. What is the difference between the highest and the second highest Balance of Payment (as % of service exports) of Mongolia?
Provide a succinct answer. 4.64. What is the difference between the highest and the second highest Balance of Payment (as % of service exports) in Netherlands?
Provide a short and direct response. 0.12. What is the difference between the highest and the lowest Balance of Payment (as % of service exports) in Europe(all income levels)?
Provide a short and direct response. 1.81. What is the difference between the highest and the lowest Balance of Payment (as % of service exports) in Malta?
Your answer should be compact. 1.5. What is the difference between the highest and the lowest Balance of Payment (as % of service exports) in Mongolia?
Provide a succinct answer. 13.61. What is the difference between the highest and the lowest Balance of Payment (as % of service exports) of Netherlands?
Keep it short and to the point. 0.53. 